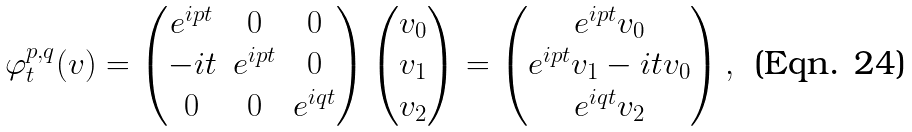<formula> <loc_0><loc_0><loc_500><loc_500>\varphi _ { t } ^ { p , q } ( v ) = \begin{pmatrix} e ^ { i p t } & 0 & 0 \\ - i t & e ^ { i p t } & 0 \\ 0 & 0 & e ^ { i q t } \end{pmatrix} \begin{pmatrix} v _ { 0 } \\ v _ { 1 } \\ v _ { 2 } \end{pmatrix} = \begin{pmatrix} e ^ { i p t } v _ { 0 } \\ e ^ { i p t } v _ { 1 } - i t v _ { 0 } \\ e ^ { i q t } v _ { 2 } \end{pmatrix} ,</formula> 